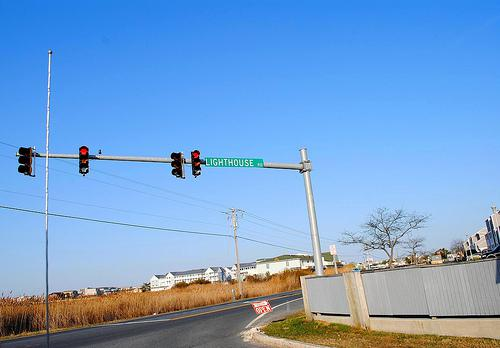Question: how many stoplights are there?
Choices:
A. Four.
B. Three.
C. Two.
D. One.
Answer with the letter. Answer: A Question: where was the photo taken?
Choices:
A. Inside.
B. On the street.
C. A park.
D. A beach.
Answer with the letter. Answer: B Question: what color is the pavement?
Choices:
A. Gray.
B. White.
C. Brown.
D. Black.
Answer with the letter. Answer: A Question: what does the green sign say?
Choices:
A. Welcome.
B. Museum.
C. Library.
D. Lighthouse.
Answer with the letter. Answer: D 